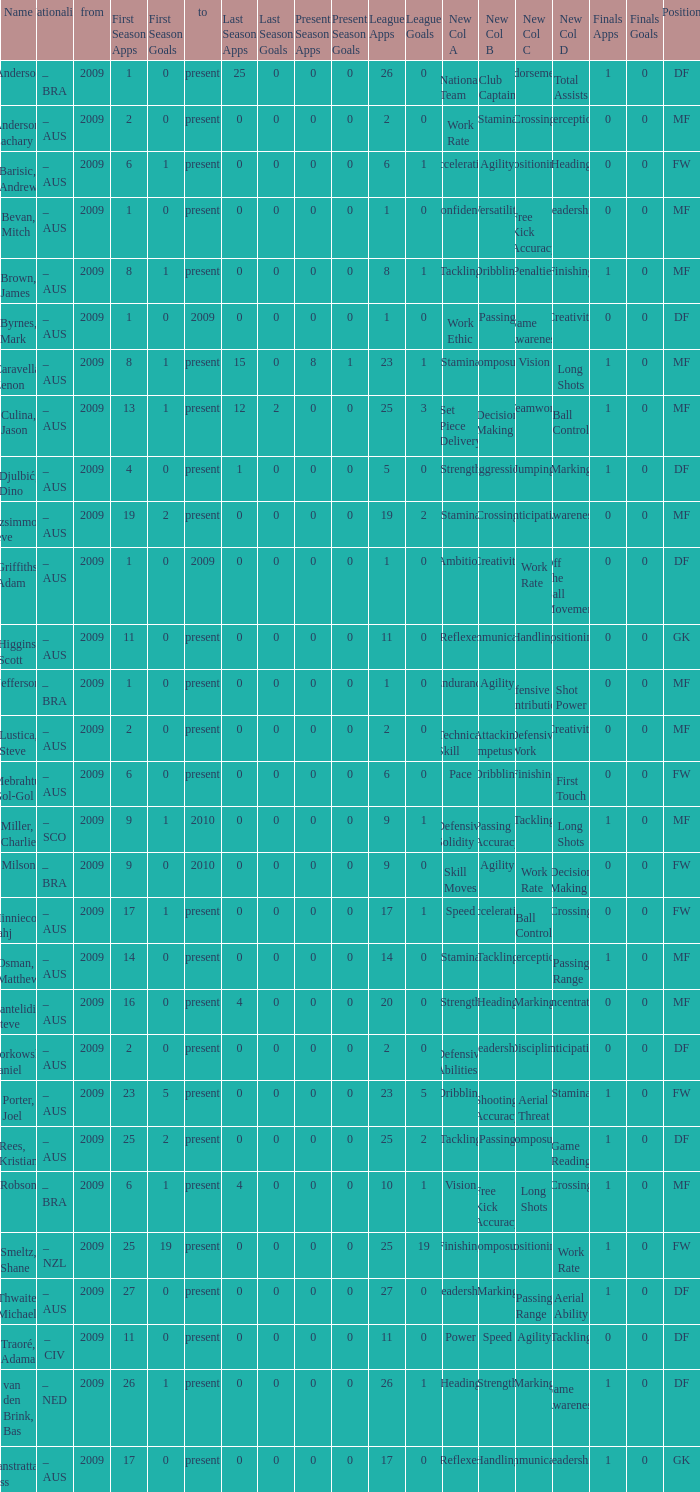Name the to for 19 league apps Present. 